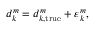<formula> <loc_0><loc_0><loc_500><loc_500>\begin{array} { r } { d _ { k } ^ { m } = d _ { k , t r u e } ^ { m } + \varepsilon _ { k } ^ { m } , } \end{array}</formula> 